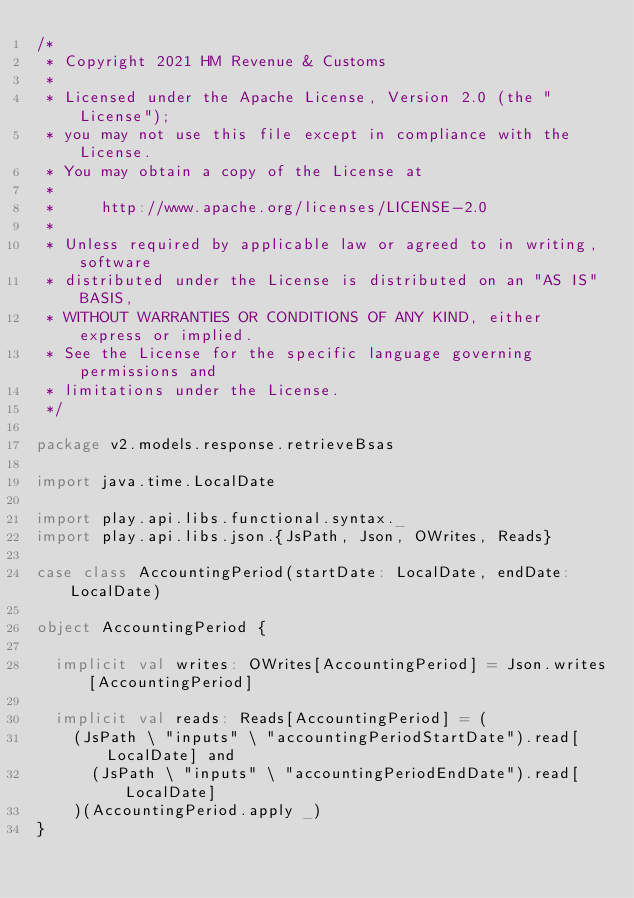<code> <loc_0><loc_0><loc_500><loc_500><_Scala_>/*
 * Copyright 2021 HM Revenue & Customs
 *
 * Licensed under the Apache License, Version 2.0 (the "License");
 * you may not use this file except in compliance with the License.
 * You may obtain a copy of the License at
 *
 *     http://www.apache.org/licenses/LICENSE-2.0
 *
 * Unless required by applicable law or agreed to in writing, software
 * distributed under the License is distributed on an "AS IS" BASIS,
 * WITHOUT WARRANTIES OR CONDITIONS OF ANY KIND, either express or implied.
 * See the License for the specific language governing permissions and
 * limitations under the License.
 */

package v2.models.response.retrieveBsas

import java.time.LocalDate

import play.api.libs.functional.syntax._
import play.api.libs.json.{JsPath, Json, OWrites, Reads}

case class AccountingPeriod(startDate: LocalDate, endDate: LocalDate)

object AccountingPeriod {

  implicit val writes: OWrites[AccountingPeriod] = Json.writes[AccountingPeriod]

  implicit val reads: Reads[AccountingPeriod] = (
    (JsPath \ "inputs" \ "accountingPeriodStartDate").read[LocalDate] and
      (JsPath \ "inputs" \ "accountingPeriodEndDate").read[LocalDate]
    )(AccountingPeriod.apply _)
}
</code> 